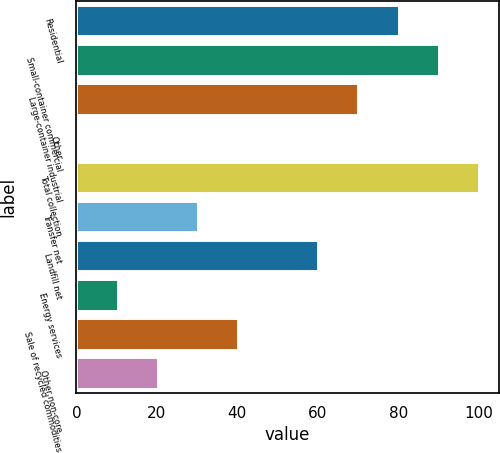Convert chart to OTSL. <chart><loc_0><loc_0><loc_500><loc_500><bar_chart><fcel>Residential<fcel>Small-container commercial<fcel>Large-container industrial<fcel>Other<fcel>Total collection<fcel>Transfer net<fcel>Landfill net<fcel>Energy services<fcel>Sale of recycled commodities<fcel>Other non-core<nl><fcel>80.08<fcel>90.04<fcel>70.12<fcel>0.4<fcel>100<fcel>30.28<fcel>60.16<fcel>10.36<fcel>40.24<fcel>20.32<nl></chart> 